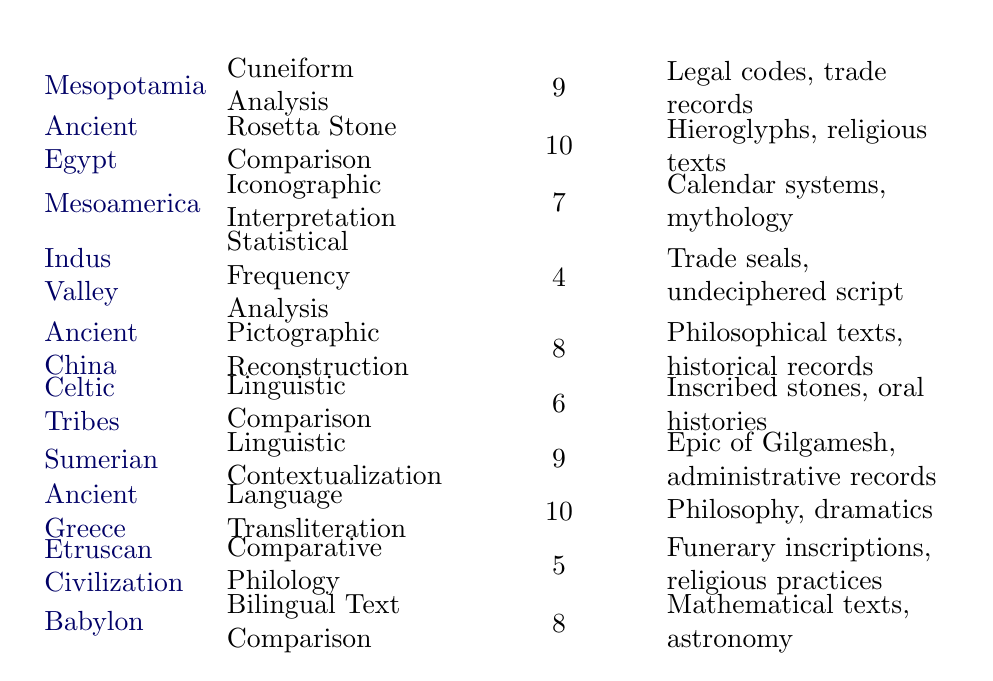What is the effectiveness rating for the Decipherment Technique used in Ancient Egypt? From the table, the effectiveness rating for Ancient Egypt's decipherment technique (Rosetta Stone Comparison) is directly listed as 10.
Answer: 10 Which civilization used the Linguistic Comparison technique? The table shows that the Celtic Tribes used the Linguistic Comparison technique.
Answer: Celtic Tribes What are the Sample Findings for the Sumerian civilization? Looking at the row for Sumerian civilization, the Sample Findings are noted as "Epic of Gilgamesh, administrative records."
Answer: Epic of Gilgamesh, administrative records What is the average effectiveness rating of all the civilizations listed? First, we sum all the effectiveness ratings: 9 + 10 + 7 + 4 + 8 + 6 + 9 + 10 + 5 + 8 = 76. There are 10 civilizations, so the average is 76 / 10 = 7.6.
Answer: 7.6 Is the effectiveness of Statistical Frequency Analysis higher than that of Iconographic Interpretation? The effectiveness rating for Statistical Frequency Analysis is 4, while that for Iconographic Interpretation is 7. Since 4 is not higher than 7, the answer is no.
Answer: No Which decipherment techniques have an effectiveness rating of 8? By checking the effectiveness ratings, the techniques with ratings of 8 are Pictographic Reconstruction (Ancient China) and Bilingual Text Comparison (Babylon).
Answer: Pictographic Reconstruction, Bilingual Text Comparison For which civilization is the effectiveness rating 6, and what is its corresponding decipherment technique? The table indicates that for the Celtic Tribes, the effectiveness rating is 6, and the associated decipherment technique is Linguistic Comparison.
Answer: Celtic Tribes, Linguistic Comparison Which civilization has the lowest effectiveness rating, and what technique did they use? From the table, the Indus Valley civilization has the lowest effectiveness rating of 4, using the technique of Statistical Frequency Analysis.
Answer: Indus Valley, Statistical Frequency Analysis Is the effectiveness of the Cuneiform Analysis technique equal to or greater than 8? The effectiveness of Cuneiform Analysis is 9. Since 9 is greater than 8, the answer is yes.
Answer: Yes 